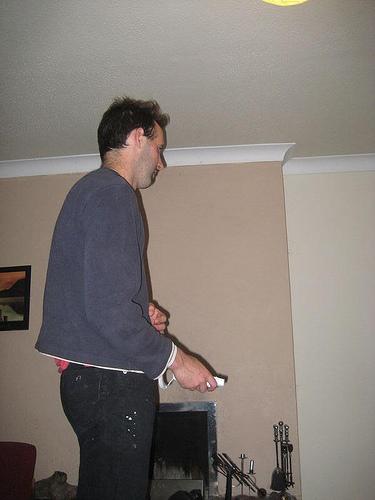What is the man in the foreground doing?
Write a very short answer. Playing wii. What color is the wall?
Write a very short answer. Beige. What color is his shirt?
Be succinct. Blue. Is he growing facial hair?
Write a very short answer. Yes. Is this man having fun?
Write a very short answer. Yes. What pattern is on the man's shirt?
Write a very short answer. Solid. What is the man playing?
Answer briefly. Wii. 